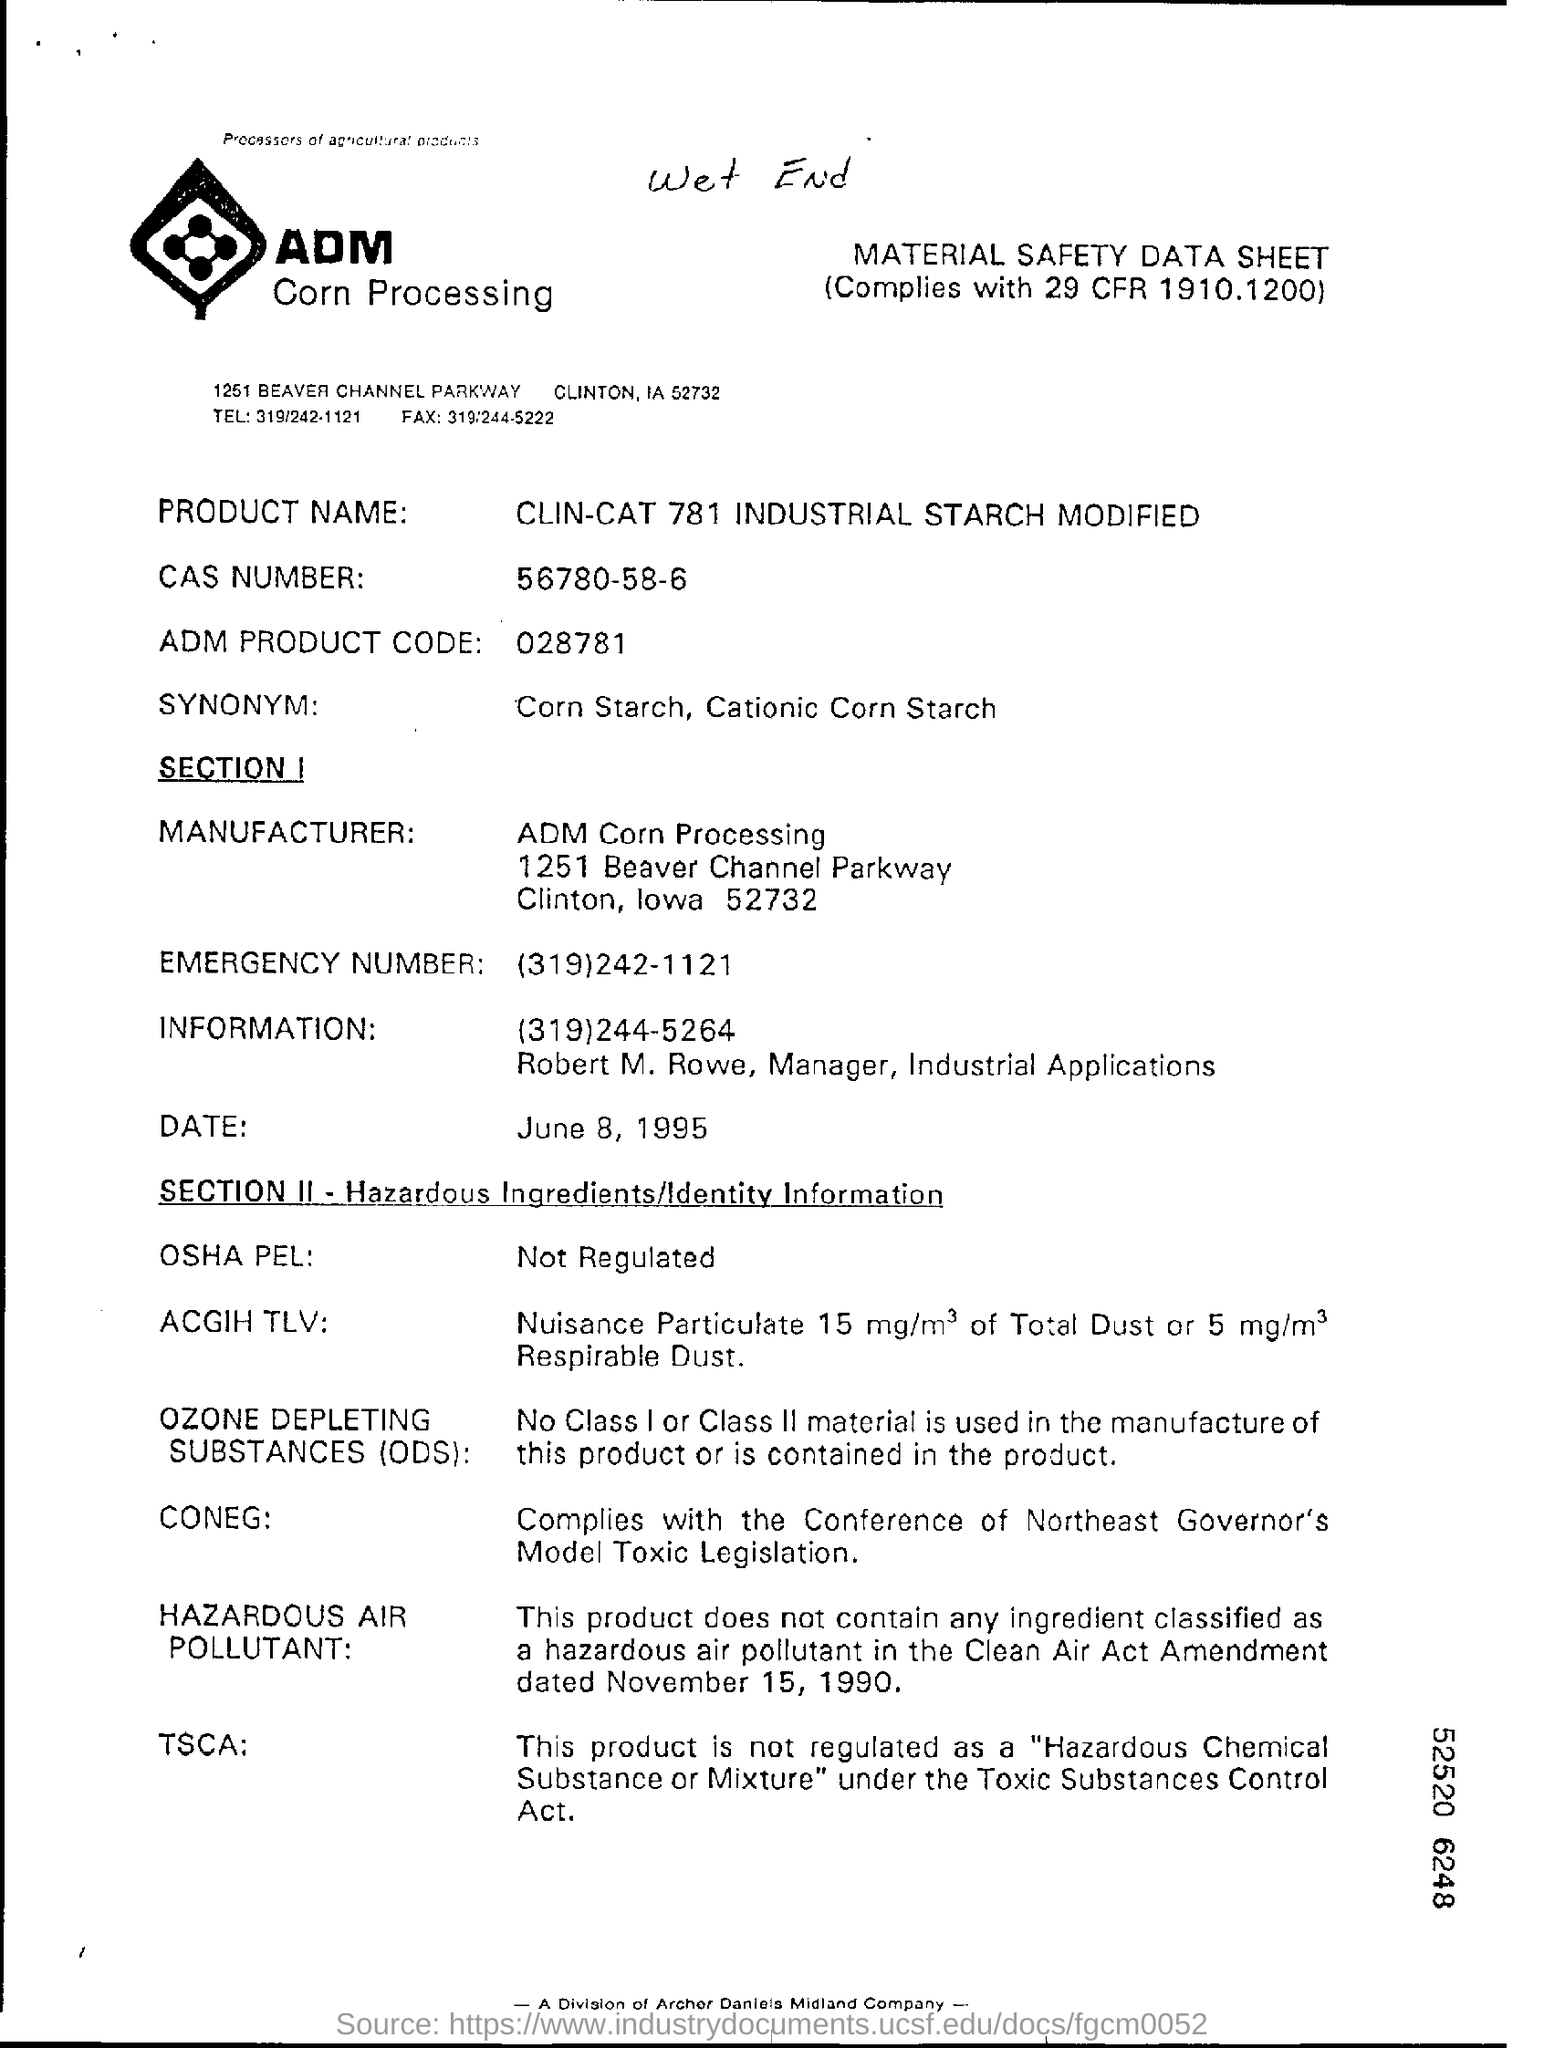What is hand written on top of this document?
Offer a terse response. Wet end. 